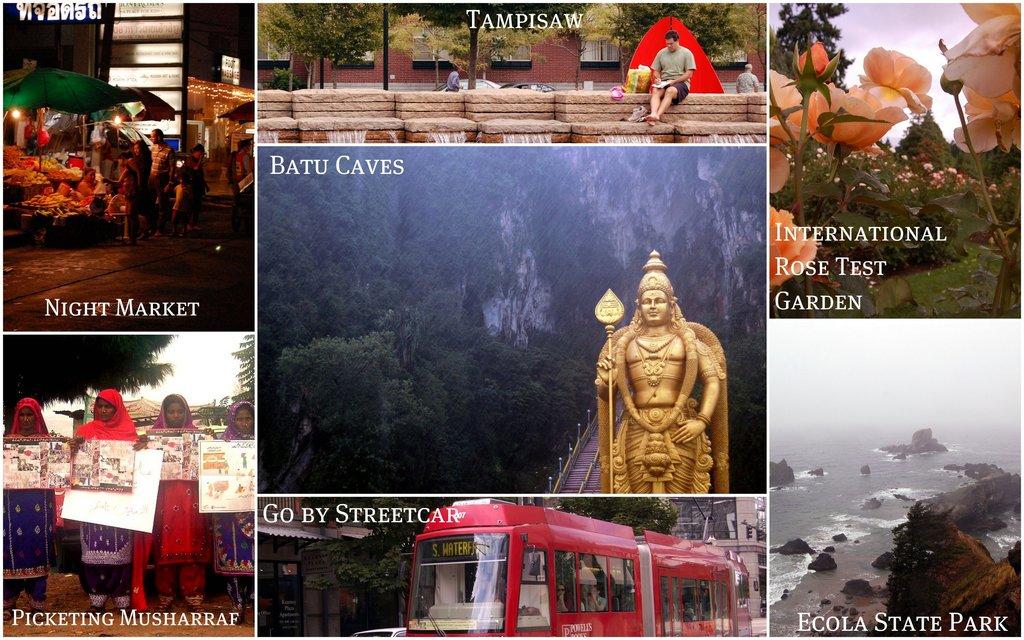What location has a gold statue out front?
Keep it short and to the point. Batu caves. What is the name of the park?
Ensure brevity in your answer.  Ecola state park. 